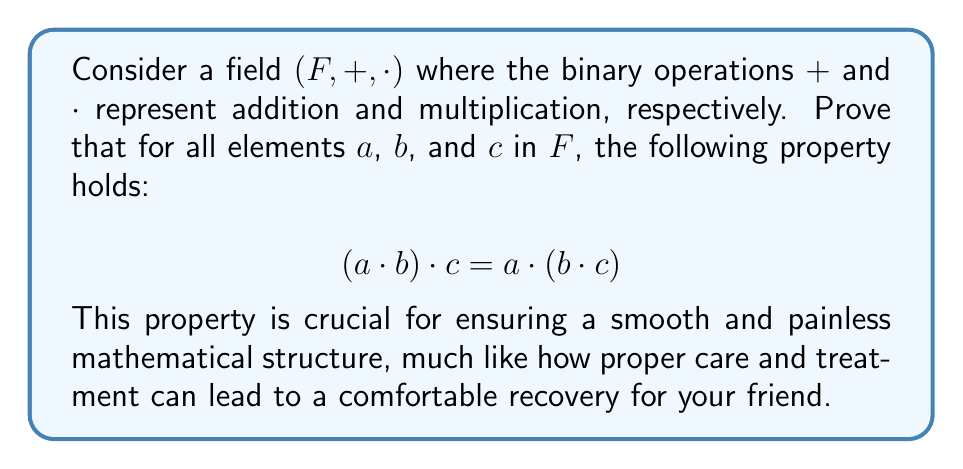Can you answer this question? To prove the associativity of multiplication in a field, we'll use the field axioms and properties:

1) First, recall that a field $(F, +, \cdot)$ satisfies the following axioms:
   - $(F, +)$ is an abelian group
   - $(F \setminus \{0\}, \cdot)$ is an abelian group
   - Distributivity of multiplication over addition

2) The associativity of multiplication is one of the group axioms for $(F \setminus \{0\}, \cdot)$. This means that for all non-zero elements $a$, $b$, and $c$ in $F$:

   $$(a \cdot b) \cdot c = a \cdot (b \cdot c)$$

3) We need to show that this property also holds when any of $a$, $b$, or $c$ is zero. Let's consider each case:

   Case 1: If $a = 0$, then:
   $$(0 \cdot b) \cdot c = 0 \cdot c = 0$$
   $$0 \cdot (b \cdot c) = 0$$
   
   Case 2: If $b = 0$, then:
   $$(a \cdot 0) \cdot c = 0 \cdot c = 0$$
   $$a \cdot (0 \cdot c) = a \cdot 0 = 0$$
   
   Case 3: If $c = 0$, then:
   $$(a \cdot b) \cdot 0 = 0$$
   $$a \cdot (b \cdot 0) = a \cdot 0 = 0$$

4) In all cases, both sides of the equation are equal, proving that the associativity of multiplication holds for all elements in $F$, including zero.

Therefore, we have proven that for all elements $a$, $b$, and $c$ in $F$:

$$(a \cdot b) \cdot c = a \cdot (b \cdot c)$$

This associativity property ensures a consistent and well-behaved multiplication operation in the field, providing a solid foundation for further mathematical explorations.
Answer: Associativity of multiplication holds for all elements in $F$. 